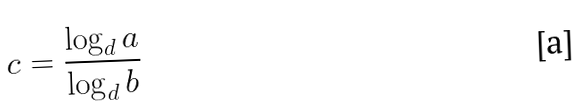<formula> <loc_0><loc_0><loc_500><loc_500>c = \frac { \log _ { d } a } { \log _ { d } b }</formula> 